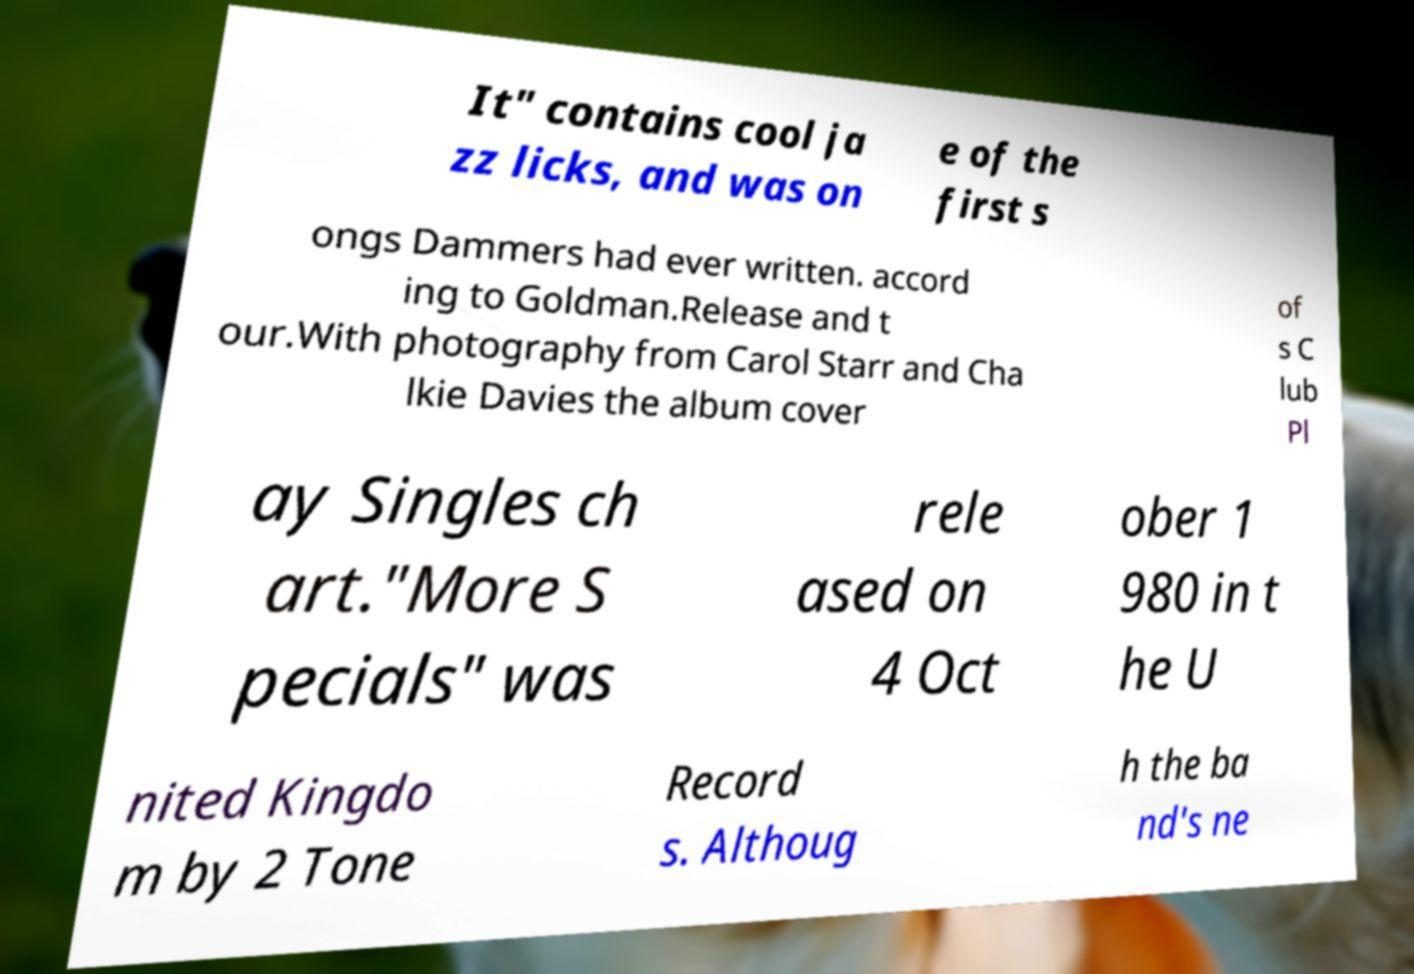Please read and relay the text visible in this image. What does it say? It" contains cool ja zz licks, and was on e of the first s ongs Dammers had ever written. accord ing to Goldman.Release and t our.With photography from Carol Starr and Cha lkie Davies the album cover of s C lub Pl ay Singles ch art."More S pecials" was rele ased on 4 Oct ober 1 980 in t he U nited Kingdo m by 2 Tone Record s. Althoug h the ba nd's ne 